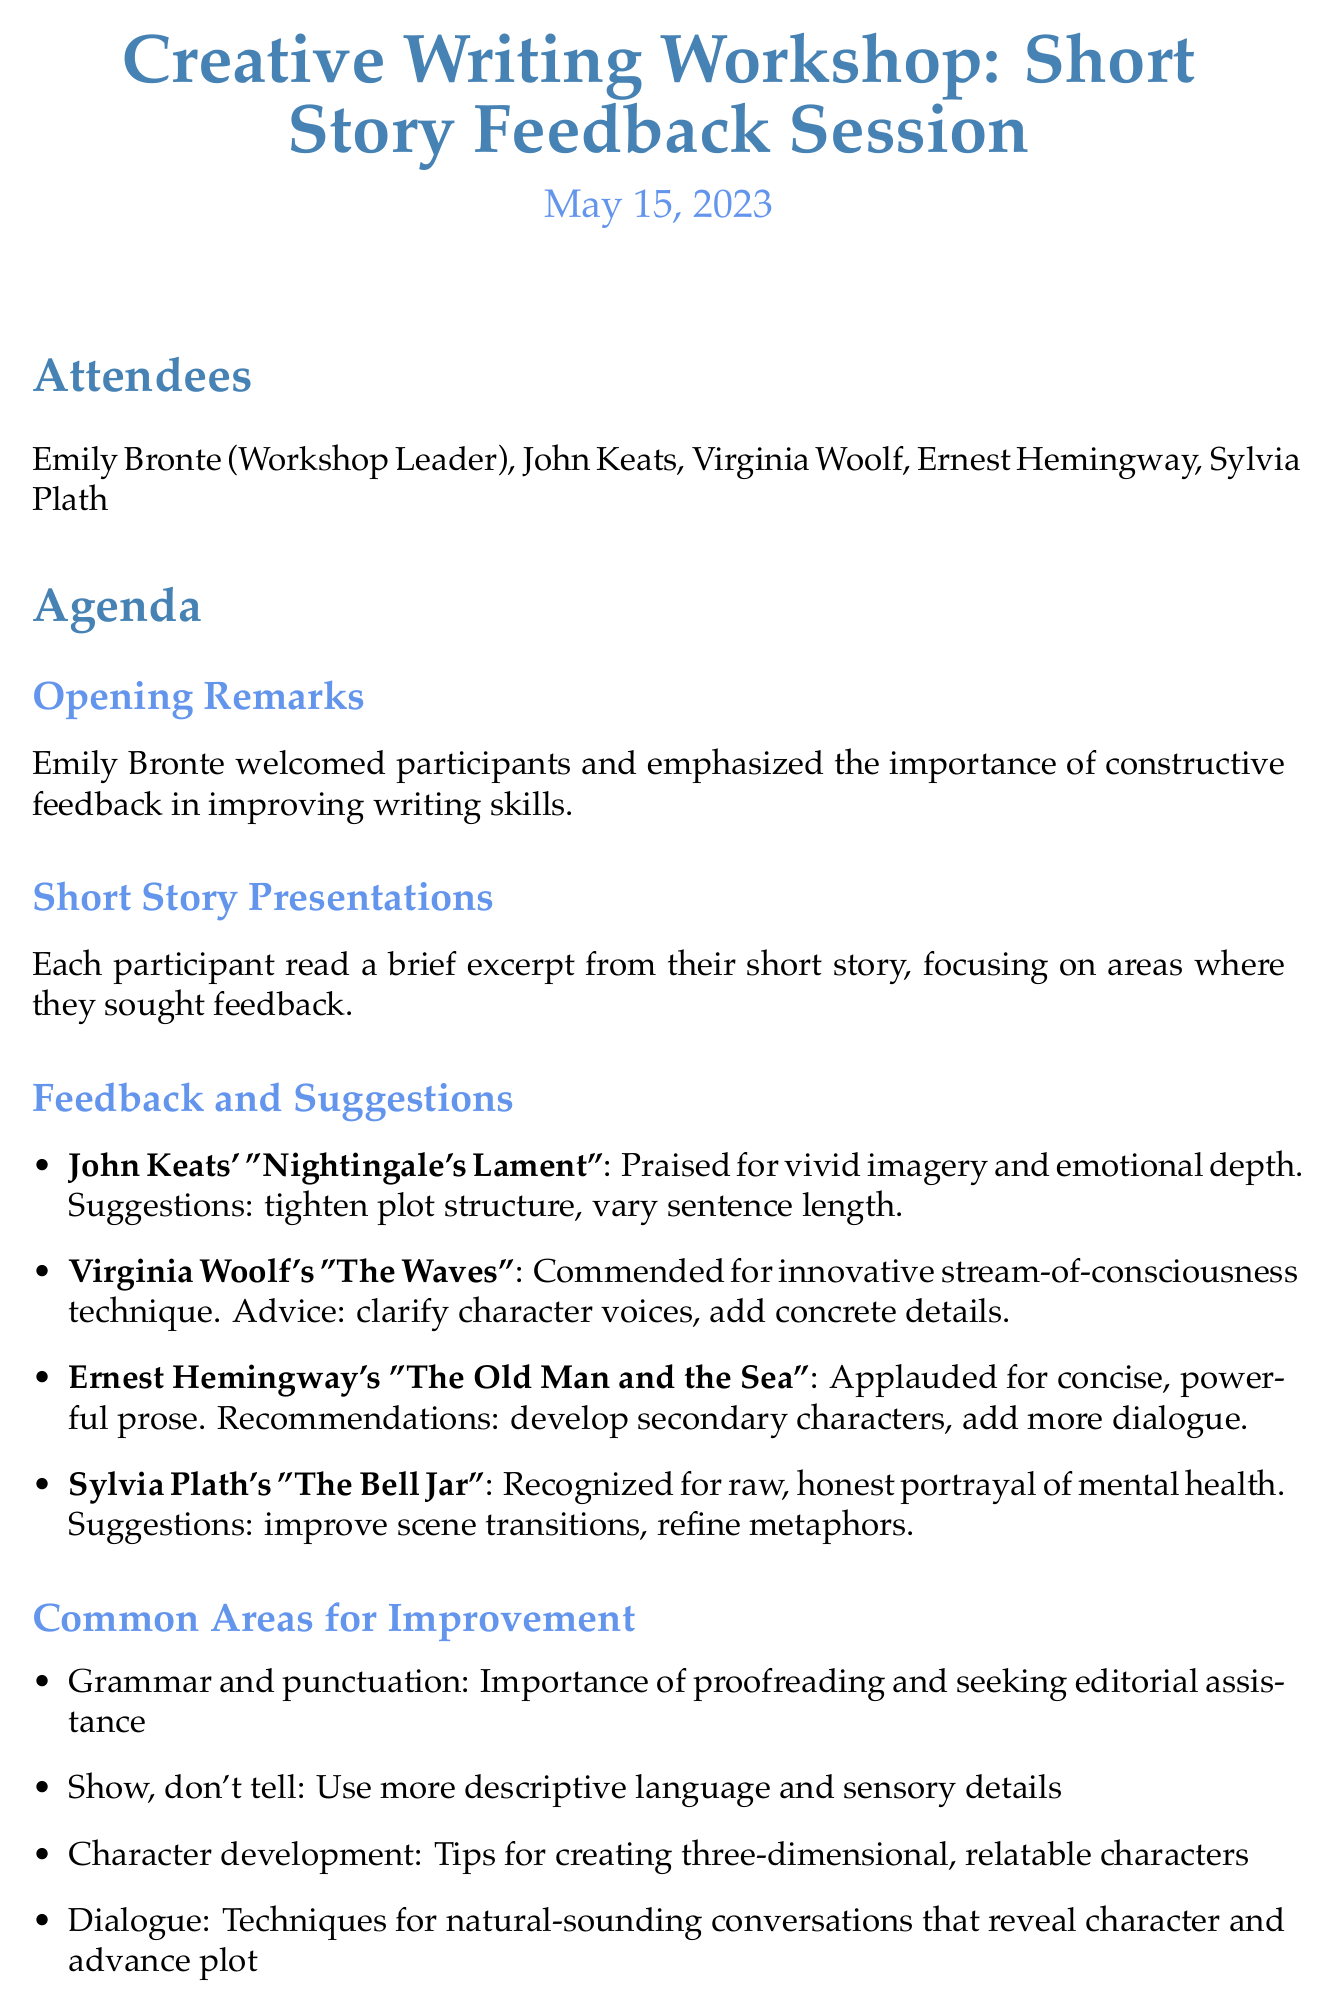who led the workshop? The workshop leader is a key figure mentioned in the document, specifically named at the beginning.
Answer: Emily Bronte what was the date of the workshop? The date provides important context for the meeting, mentioned prominently in the document.
Answer: May 15, 2023 which story received praise for vivid imagery? This question focuses on the specific feedback given in the session regarding participants' short stories.
Answer: Nightingale's Lament what common area for improvement emphasizes proofreading? The common areas for improvement highlight essential writing skills discussed during the session.
Answer: Grammar and punctuation how long was the free-writing exercise? This detail refers to a specific activity during the workshop and is a straightforward retrieval question.
Answer: 15 minutes which participant's story used an innovative technique? This question combines feedback with reasoning about the style employed by participants in their writing.
Answer: Virginia Woolf what is an action item for Emily Bronte? Action items reflect the commitments made during the meeting, indicating follow-up tasks for attendees.
Answer: circulate a list of recommended grammar and punctuation resources how many attendees were present at the workshop? This question quantifies participation and is based on the attendees listed in the document.
Answer: five which story was recognized for its portrayal of mental health? This question involves recognizing the specific works discussed and their thematic elements emphasized in the feedback.
Answer: The Bell Jar 